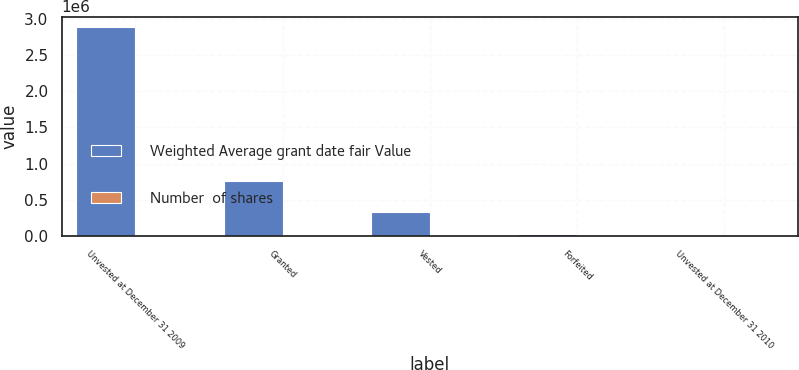Convert chart to OTSL. <chart><loc_0><loc_0><loc_500><loc_500><stacked_bar_chart><ecel><fcel>Unvested at December 31 2009<fcel>Granted<fcel>Vested<fcel>Forfeited<fcel>Unvested at December 31 2010<nl><fcel>Weighted Average grant date fair Value<fcel>2.89234e+06<fcel>755616<fcel>335106<fcel>22579<fcel>34.73<nl><fcel>Number  of shares<fcel>24.04<fcel>34.73<fcel>26.26<fcel>25.44<fcel>26.26<nl></chart> 